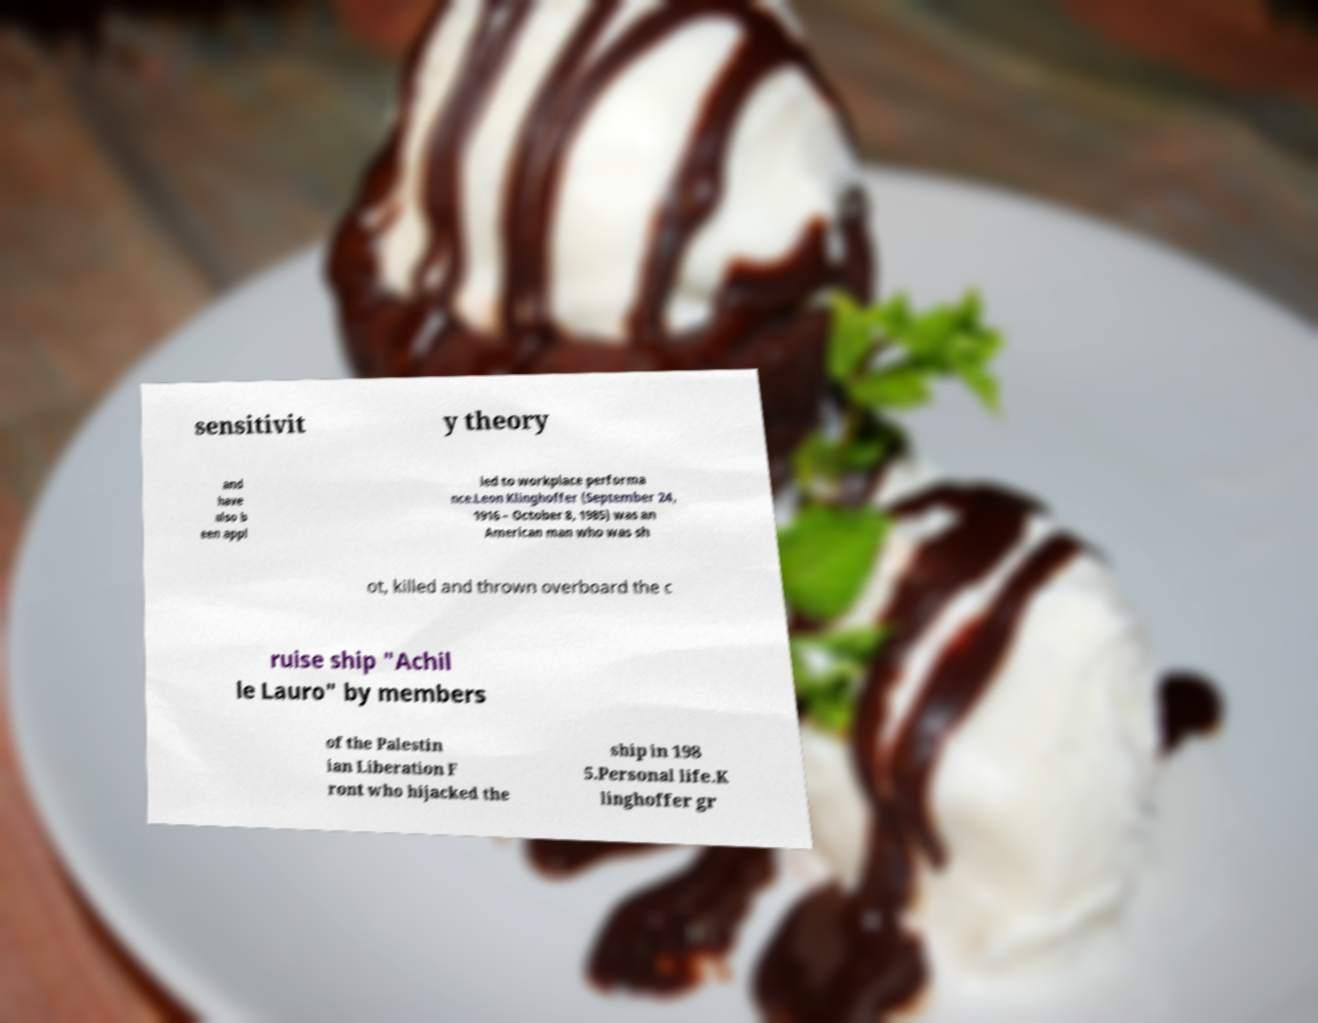Could you extract and type out the text from this image? sensitivit y theory and have also b een appl ied to workplace performa nce.Leon Klinghoffer (September 24, 1916 – October 8, 1985) was an American man who was sh ot, killed and thrown overboard the c ruise ship "Achil le Lauro" by members of the Palestin ian Liberation F ront who hijacked the ship in 198 5.Personal life.K linghoffer gr 